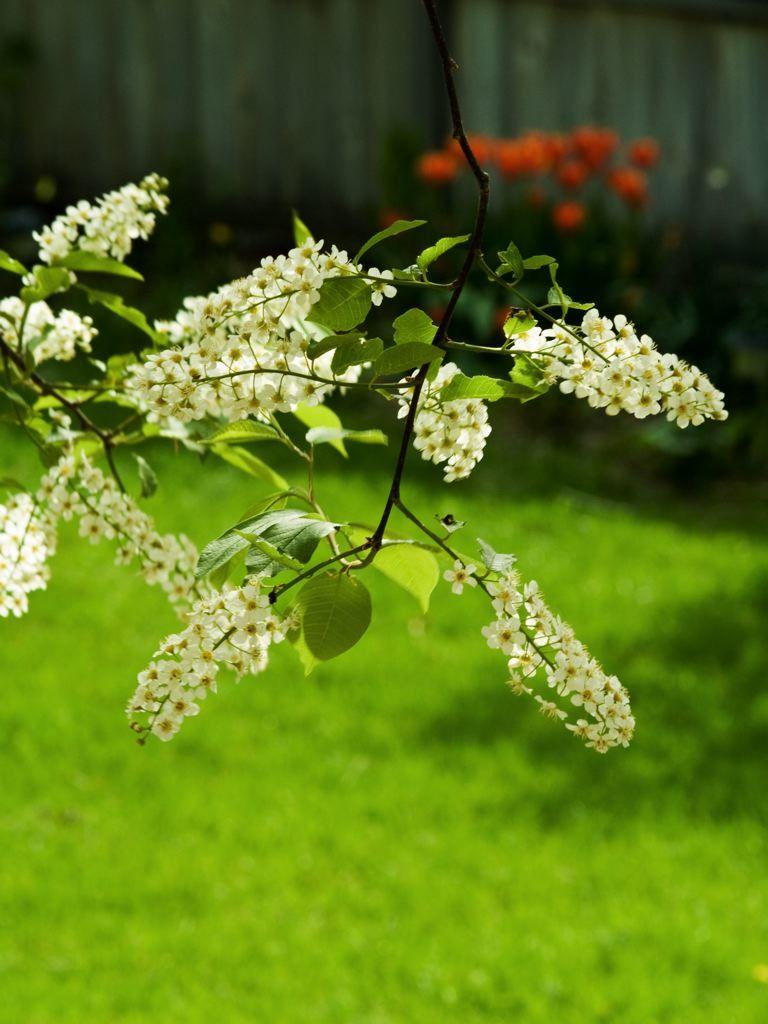What type of plant life is present in the image? There are flowers in the image. Can you describe the flowers in more detail? The flowers have leaves and a stem. What is the ground made of in the image? There is a grassy land at the bottom of the image. What can be seen in the background of the image? There appears to be a wall in the background of the image. What type of weather can be seen in the image, with the presence of thunder and mist? There is no mention of thunder or mist in the image; it only shows flowers, leaves, stems, grassy land, and a wall in the background. 